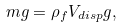Convert formula to latex. <formula><loc_0><loc_0><loc_500><loc_500>m g = \rho _ { f } V _ { d i s p } g ,</formula> 